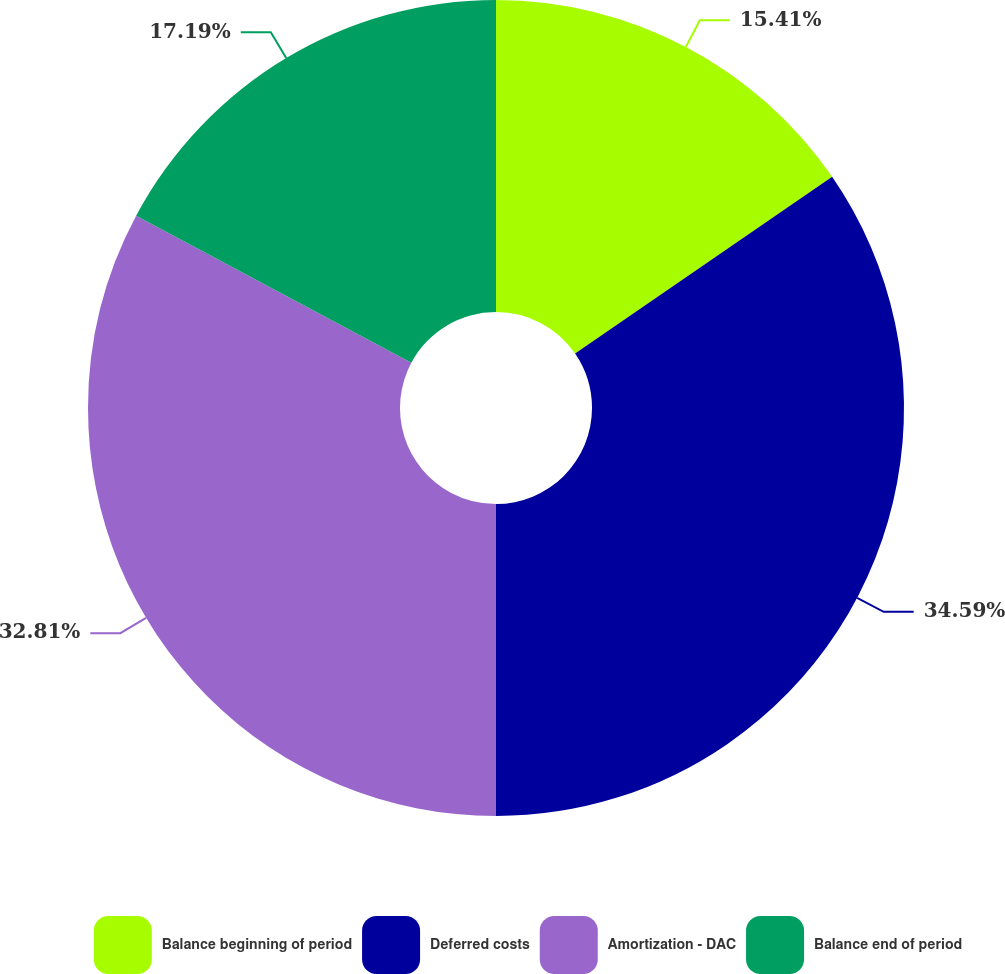Convert chart to OTSL. <chart><loc_0><loc_0><loc_500><loc_500><pie_chart><fcel>Balance beginning of period<fcel>Deferred costs<fcel>Amortization - DAC<fcel>Balance end of period<nl><fcel>15.41%<fcel>34.59%<fcel>32.81%<fcel>17.19%<nl></chart> 